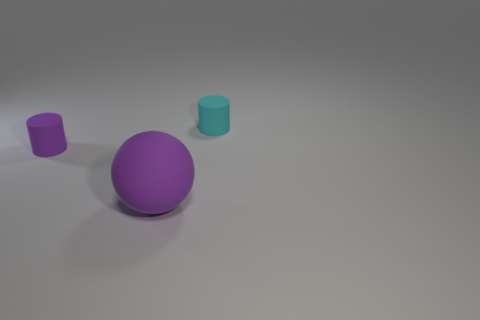Add 3 small purple things. How many objects exist? 6 Subtract all cylinders. How many objects are left? 1 Subtract all brown rubber balls. Subtract all small cyan rubber objects. How many objects are left? 2 Add 2 tiny matte cylinders. How many tiny matte cylinders are left? 4 Add 2 tiny rubber objects. How many tiny rubber objects exist? 4 Subtract 0 green cylinders. How many objects are left? 3 